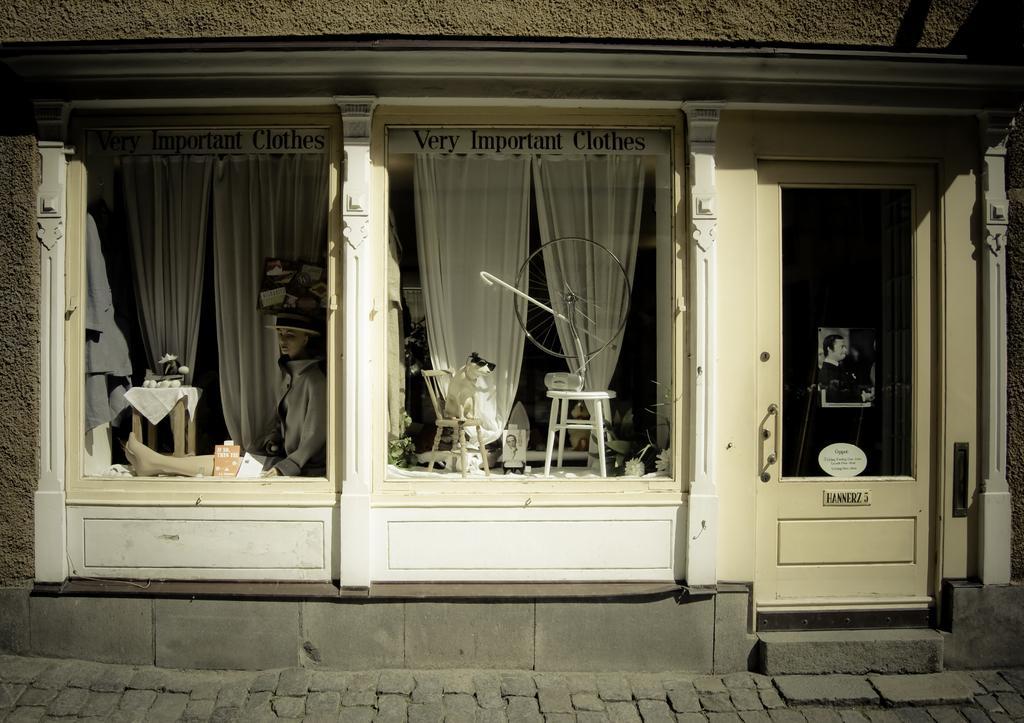Could you give a brief overview of what you see in this image? In this image there is a building having a door at the right side of the image. On the door there is a poster attached to it. Beside there are two windows. Behind the window there is a table having a metal object on it. Beside there is a chair having an animal standing on it. On the other window there is a person sitting on the floor. Beside him there is a table having few objects on it. Beside him there is a curtain. Bottom of image there is cobblestone path. 